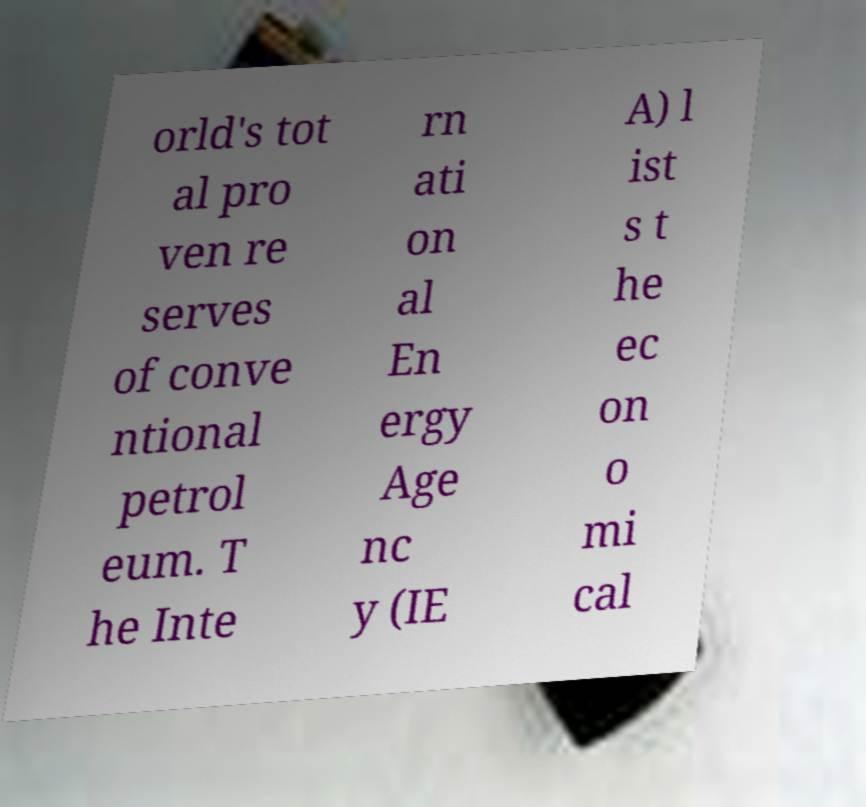Can you read and provide the text displayed in the image?This photo seems to have some interesting text. Can you extract and type it out for me? orld's tot al pro ven re serves of conve ntional petrol eum. T he Inte rn ati on al En ergy Age nc y (IE A) l ist s t he ec on o mi cal 